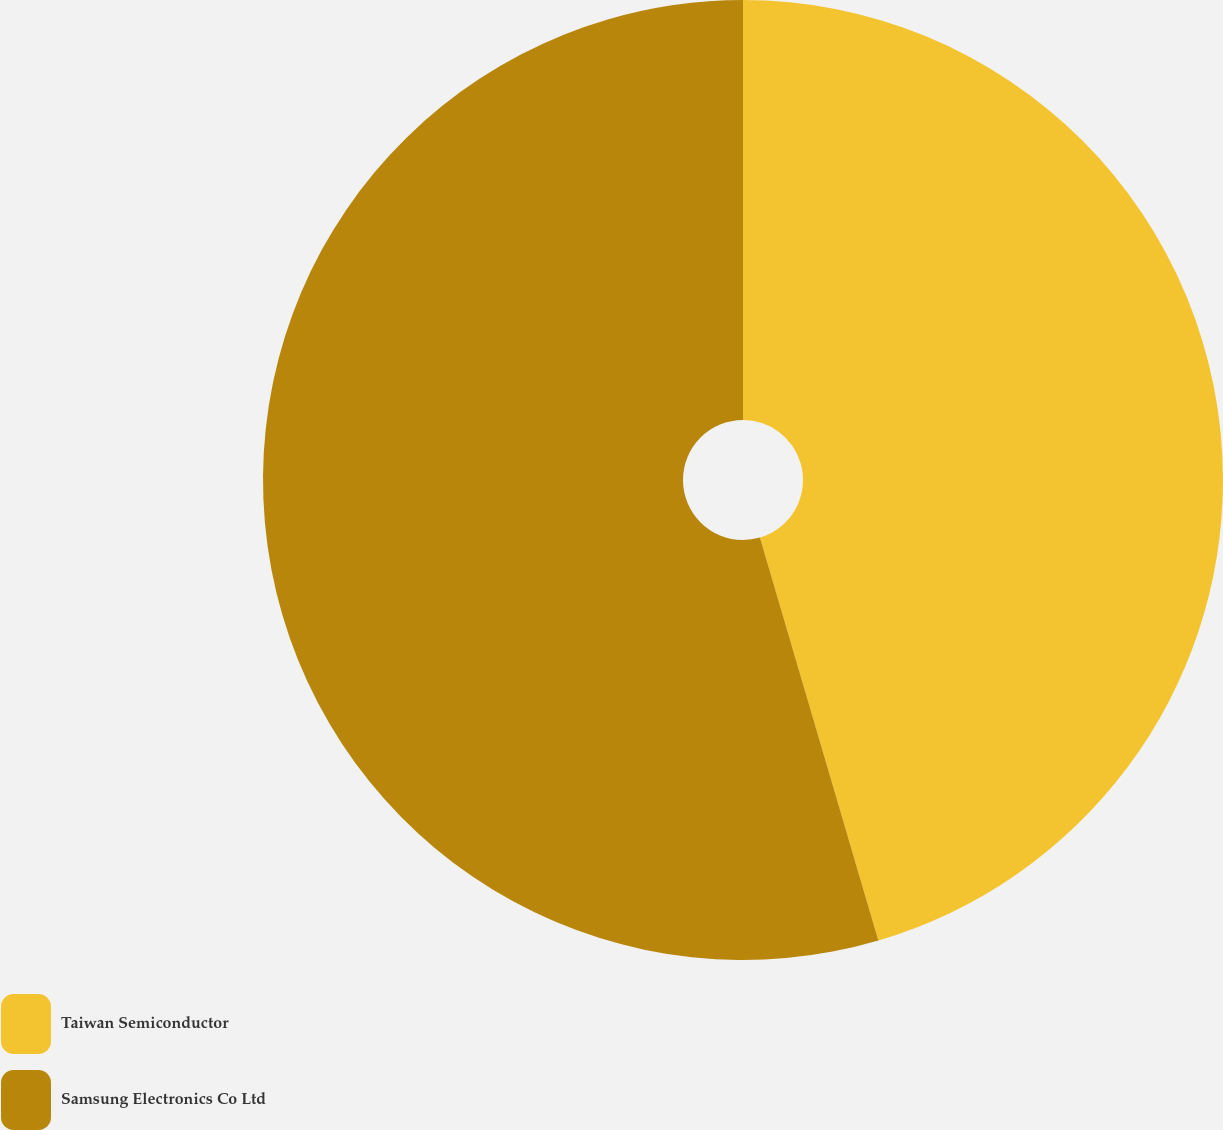<chart> <loc_0><loc_0><loc_500><loc_500><pie_chart><fcel>Taiwan Semiconductor<fcel>Samsung Electronics Co Ltd<nl><fcel>45.45%<fcel>54.55%<nl></chart> 